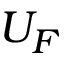<formula> <loc_0><loc_0><loc_500><loc_500>U _ { F }</formula> 